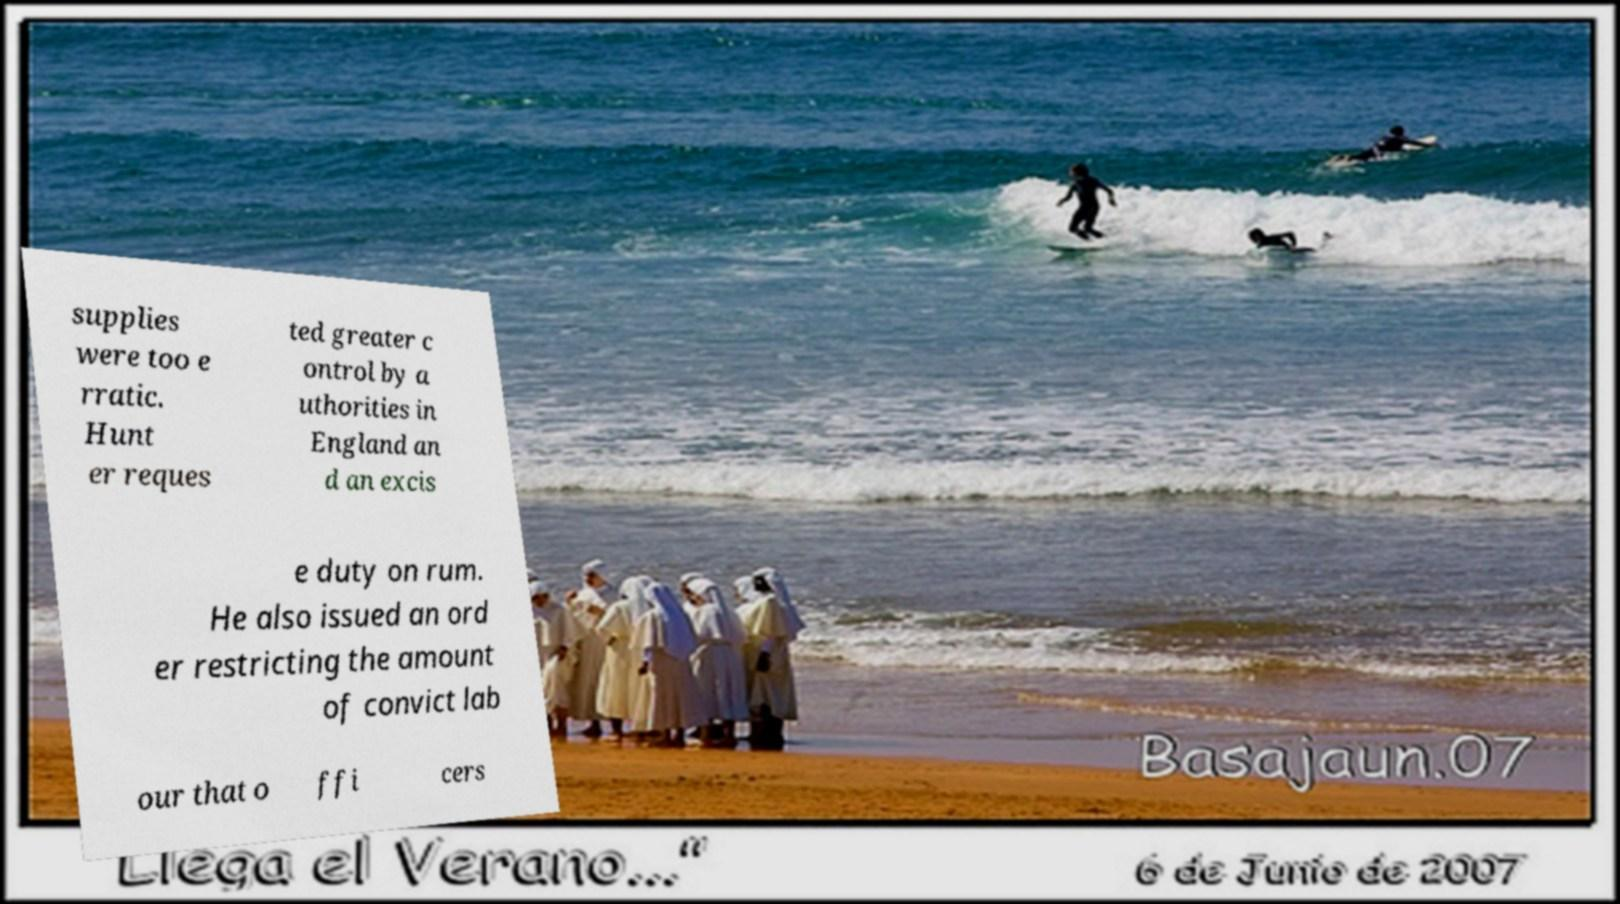What messages or text are displayed in this image? I need them in a readable, typed format. supplies were too e rratic. Hunt er reques ted greater c ontrol by a uthorities in England an d an excis e duty on rum. He also issued an ord er restricting the amount of convict lab our that o ffi cers 